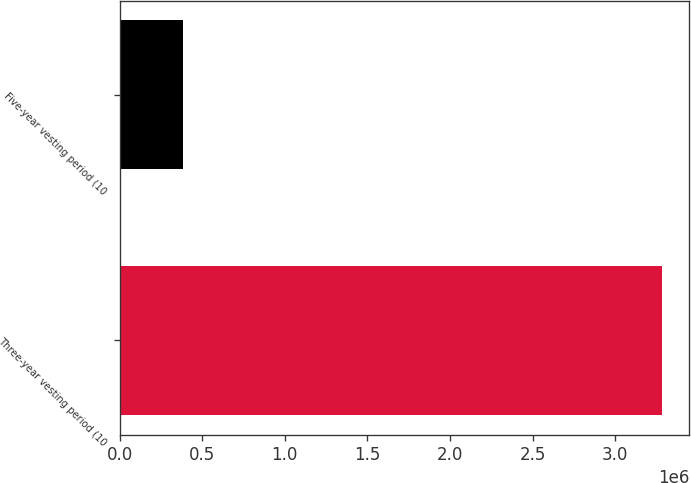Convert chart. <chart><loc_0><loc_0><loc_500><loc_500><bar_chart><fcel>Three-year vesting period (10<fcel>Five-year vesting period (10<nl><fcel>3.28553e+06<fcel>386211<nl></chart> 